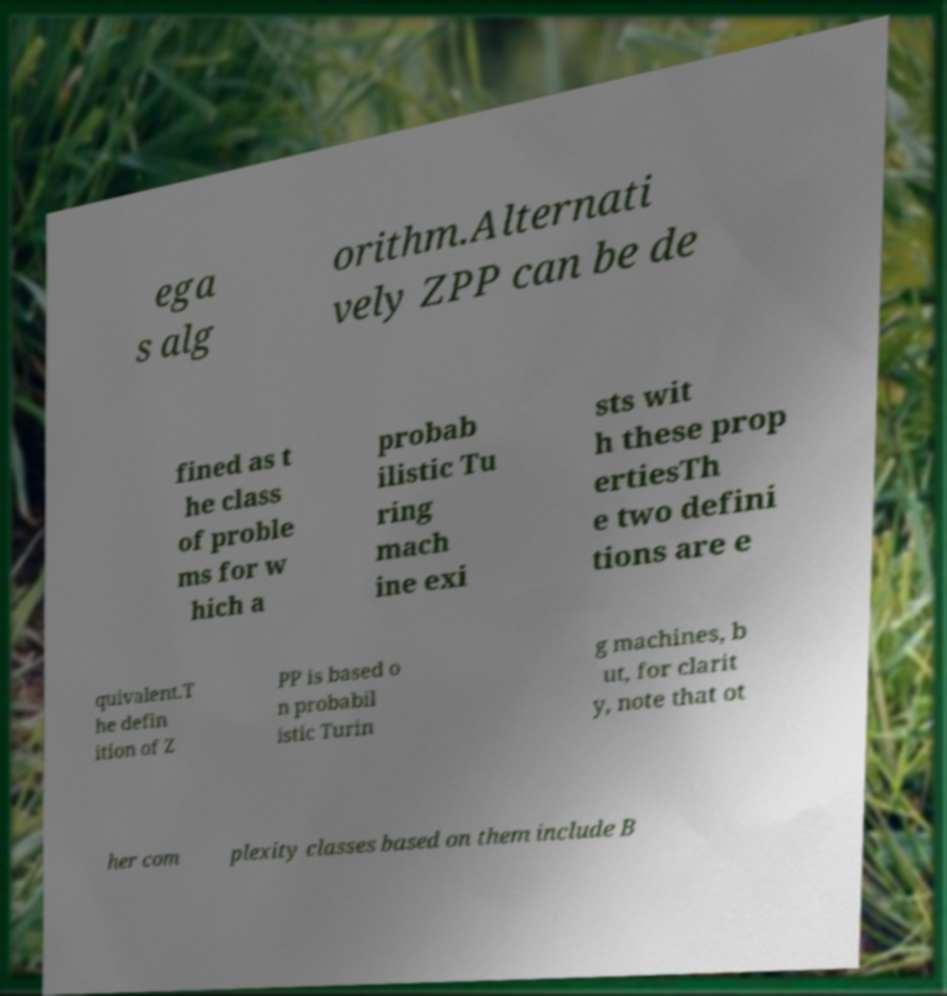There's text embedded in this image that I need extracted. Can you transcribe it verbatim? ega s alg orithm.Alternati vely ZPP can be de fined as t he class of proble ms for w hich a probab ilistic Tu ring mach ine exi sts wit h these prop ertiesTh e two defini tions are e quivalent.T he defin ition of Z PP is based o n probabil istic Turin g machines, b ut, for clarit y, note that ot her com plexity classes based on them include B 